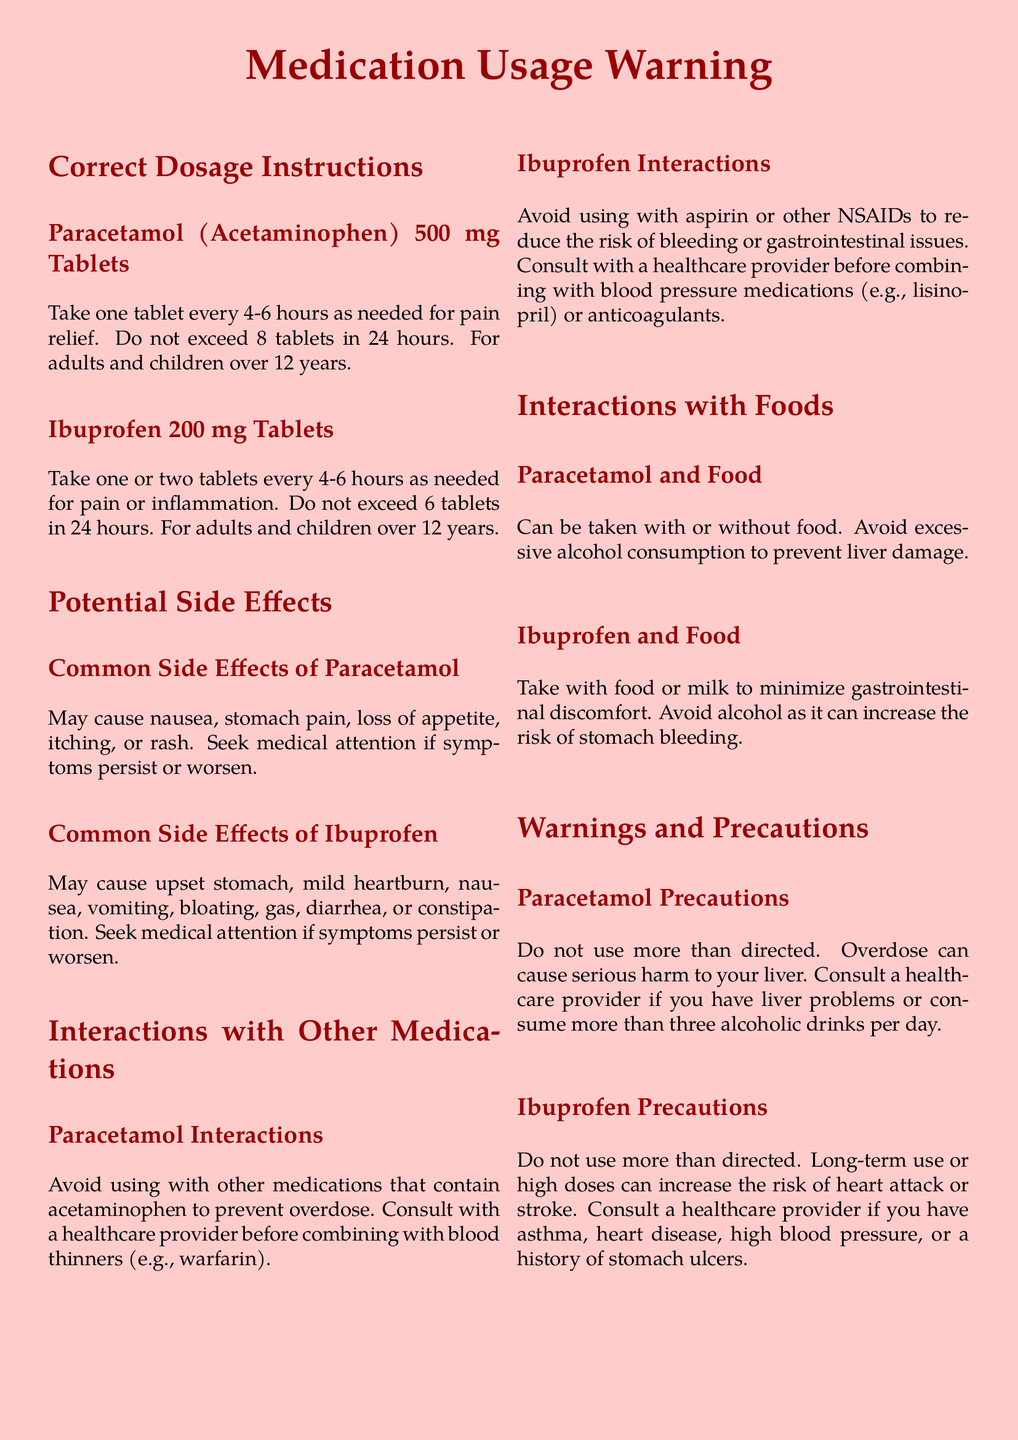What is the correct dosage for Paracetamol? The document states to take one tablet every 4-6 hours as needed for pain relief.
Answer: one tablet every 4-6 hours What is the maximum number of Ibuprofen tablets allowed in 24 hours? The maximum allowed for Ibuprofen is stated as 6 tablets in 24 hours.
Answer: 6 tablets What side effect is common with Paracetamol? The document lists nausea, stomach pain, loss of appetite, itching, or rash as common side effects.
Answer: nausea Which medication should not be used with aspirin? The document indicates that Ibuprofen should not be used with aspirin.
Answer: Ibuprofen What must be avoided while taking Paracetamol? It is advised to avoid excessive alcohol consumption to prevent liver damage.
Answer: excessive alcohol consumption What is a precaution for long-term use of Ibuprofen? The document warns that long-term use or high doses can increase the risk of heart attack or stroke.
Answer: heart attack or stroke Can you take Paracetamol with food? The document states that Paracetamol can be taken with or without food.
Answer: yes What should you do if symptoms persist after taking Ibuprofen? You should seek medical attention if symptoms persist or worsen after taking Ibuprofen.
Answer: seek medical attention 